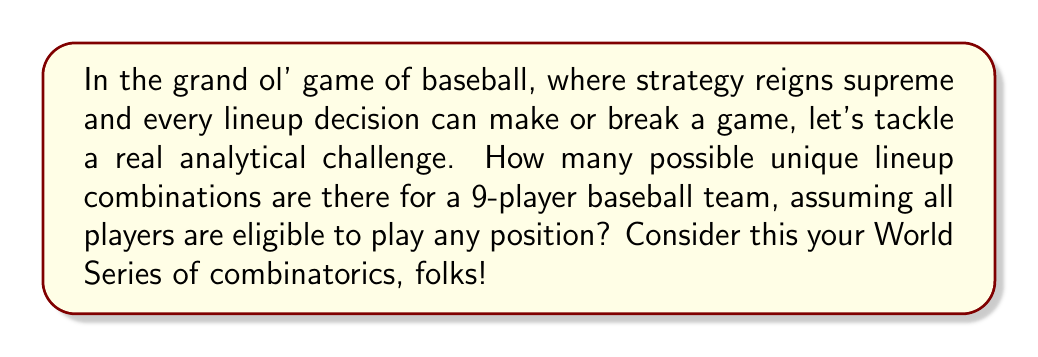Show me your answer to this math problem. Alright, baseball fans, let's break this down like we're dissecting a pitcher's repertoire:

1) In baseball, the order of the lineup matters. This is crucial, unlike in some lesser sports where substitutions can happen willy-nilly. We're dealing with a permutation here, not just a combination.

2) We have 9 players, and we need to arrange all 9 of them in a specific order. This is a textbook case of calculating permutations.

3) The formula for permutations of n distinct objects is:

   $$P(n) = n!$$

   Where $n!$ represents the factorial of n.

4) In our case, $n = 9$, so we're looking at $9!$

5) Let's calculate this step-by-step:

   $$9! = 9 \times 8 \times 7 \times 6 \times 5 \times 4 \times 3 \times 2 \times 1$$

6) Crunching these numbers:

   $$9! = 362,880$$

So, just like how a savvy manager has countless strategies up his sleeve, there are 362,880 different ways to arrange a 9-player lineup. That's more combinations than there are games in 2,244 MLB regular seasons!

This, folks, is why baseball is the thinking man's game. The sheer number of possibilities in just setting a lineup demonstrates the depth and complexity that makes America's pastime superior to other sports. You don't see this level of permutation potential in your average NBA starting five!
Answer: $$362,880$$ 